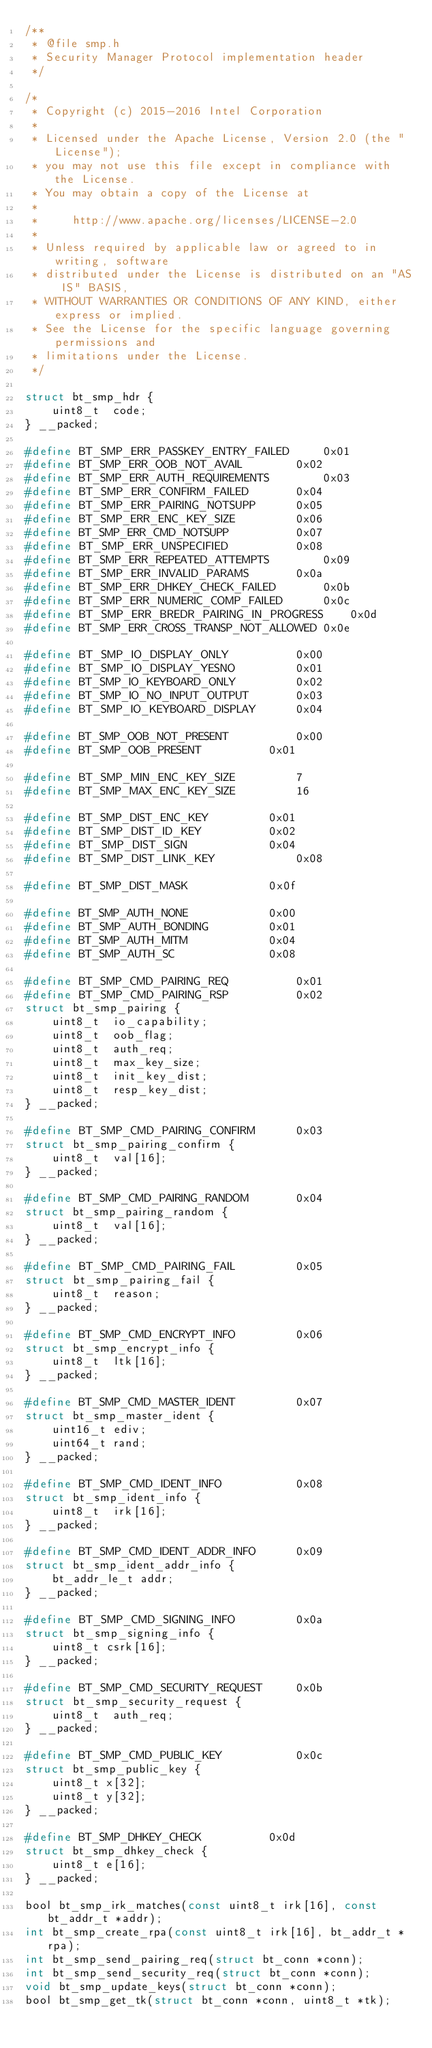Convert code to text. <code><loc_0><loc_0><loc_500><loc_500><_C_>/**
 * @file smp.h
 * Security Manager Protocol implementation header
 */

/*
 * Copyright (c) 2015-2016 Intel Corporation
 *
 * Licensed under the Apache License, Version 2.0 (the "License");
 * you may not use this file except in compliance with the License.
 * You may obtain a copy of the License at
 *
 *     http://www.apache.org/licenses/LICENSE-2.0
 *
 * Unless required by applicable law or agreed to in writing, software
 * distributed under the License is distributed on an "AS IS" BASIS,
 * WITHOUT WARRANTIES OR CONDITIONS OF ANY KIND, either express or implied.
 * See the License for the specific language governing permissions and
 * limitations under the License.
 */

struct bt_smp_hdr {
	uint8_t  code;
} __packed;

#define BT_SMP_ERR_PASSKEY_ENTRY_FAILED		0x01
#define BT_SMP_ERR_OOB_NOT_AVAIL		0x02
#define BT_SMP_ERR_AUTH_REQUIREMENTS		0x03
#define BT_SMP_ERR_CONFIRM_FAILED		0x04
#define BT_SMP_ERR_PAIRING_NOTSUPP		0x05
#define BT_SMP_ERR_ENC_KEY_SIZE			0x06
#define BT_SMP_ERR_CMD_NOTSUPP			0x07
#define BT_SMP_ERR_UNSPECIFIED			0x08
#define BT_SMP_ERR_REPEATED_ATTEMPTS		0x09
#define BT_SMP_ERR_INVALID_PARAMS		0x0a
#define BT_SMP_ERR_DHKEY_CHECK_FAILED		0x0b
#define BT_SMP_ERR_NUMERIC_COMP_FAILED		0x0c
#define BT_SMP_ERR_BREDR_PAIRING_IN_PROGRESS	0x0d
#define BT_SMP_ERR_CROSS_TRANSP_NOT_ALLOWED	0x0e

#define BT_SMP_IO_DISPLAY_ONLY			0x00
#define BT_SMP_IO_DISPLAY_YESNO			0x01
#define BT_SMP_IO_KEYBOARD_ONLY			0x02
#define BT_SMP_IO_NO_INPUT_OUTPUT		0x03
#define BT_SMP_IO_KEYBOARD_DISPLAY		0x04

#define BT_SMP_OOB_NOT_PRESENT			0x00
#define BT_SMP_OOB_PRESENT			0x01

#define BT_SMP_MIN_ENC_KEY_SIZE			7
#define BT_SMP_MAX_ENC_KEY_SIZE			16

#define BT_SMP_DIST_ENC_KEY			0x01
#define BT_SMP_DIST_ID_KEY			0x02
#define BT_SMP_DIST_SIGN			0x04
#define BT_SMP_DIST_LINK_KEY			0x08

#define BT_SMP_DIST_MASK			0x0f

#define BT_SMP_AUTH_NONE			0x00
#define BT_SMP_AUTH_BONDING			0x01
#define BT_SMP_AUTH_MITM			0x04
#define BT_SMP_AUTH_SC				0x08

#define BT_SMP_CMD_PAIRING_REQ			0x01
#define BT_SMP_CMD_PAIRING_RSP			0x02
struct bt_smp_pairing {
	uint8_t  io_capability;
	uint8_t  oob_flag;
	uint8_t  auth_req;
	uint8_t  max_key_size;
	uint8_t  init_key_dist;
	uint8_t  resp_key_dist;
} __packed;

#define BT_SMP_CMD_PAIRING_CONFIRM		0x03
struct bt_smp_pairing_confirm {
	uint8_t  val[16];
} __packed;

#define BT_SMP_CMD_PAIRING_RANDOM		0x04
struct bt_smp_pairing_random {
	uint8_t  val[16];
} __packed;

#define BT_SMP_CMD_PAIRING_FAIL			0x05
struct bt_smp_pairing_fail {
	uint8_t  reason;
} __packed;

#define BT_SMP_CMD_ENCRYPT_INFO			0x06
struct bt_smp_encrypt_info {
	uint8_t  ltk[16];
} __packed;

#define BT_SMP_CMD_MASTER_IDENT			0x07
struct bt_smp_master_ident {
	uint16_t ediv;
	uint64_t rand;
} __packed;

#define BT_SMP_CMD_IDENT_INFO			0x08
struct bt_smp_ident_info {
	uint8_t  irk[16];
} __packed;

#define BT_SMP_CMD_IDENT_ADDR_INFO		0x09
struct bt_smp_ident_addr_info {
	bt_addr_le_t addr;
} __packed;

#define BT_SMP_CMD_SIGNING_INFO			0x0a
struct bt_smp_signing_info {
	uint8_t csrk[16];
} __packed;

#define BT_SMP_CMD_SECURITY_REQUEST		0x0b
struct bt_smp_security_request {
	uint8_t  auth_req;
} __packed;

#define BT_SMP_CMD_PUBLIC_KEY			0x0c
struct bt_smp_public_key {
	uint8_t x[32];
	uint8_t y[32];
} __packed;

#define BT_SMP_DHKEY_CHECK			0x0d
struct bt_smp_dhkey_check {
	uint8_t e[16];
} __packed;

bool bt_smp_irk_matches(const uint8_t irk[16], const bt_addr_t *addr);
int bt_smp_create_rpa(const uint8_t irk[16], bt_addr_t *rpa);
int bt_smp_send_pairing_req(struct bt_conn *conn);
int bt_smp_send_security_req(struct bt_conn *conn);
void bt_smp_update_keys(struct bt_conn *conn);
bool bt_smp_get_tk(struct bt_conn *conn, uint8_t *tk);
</code> 